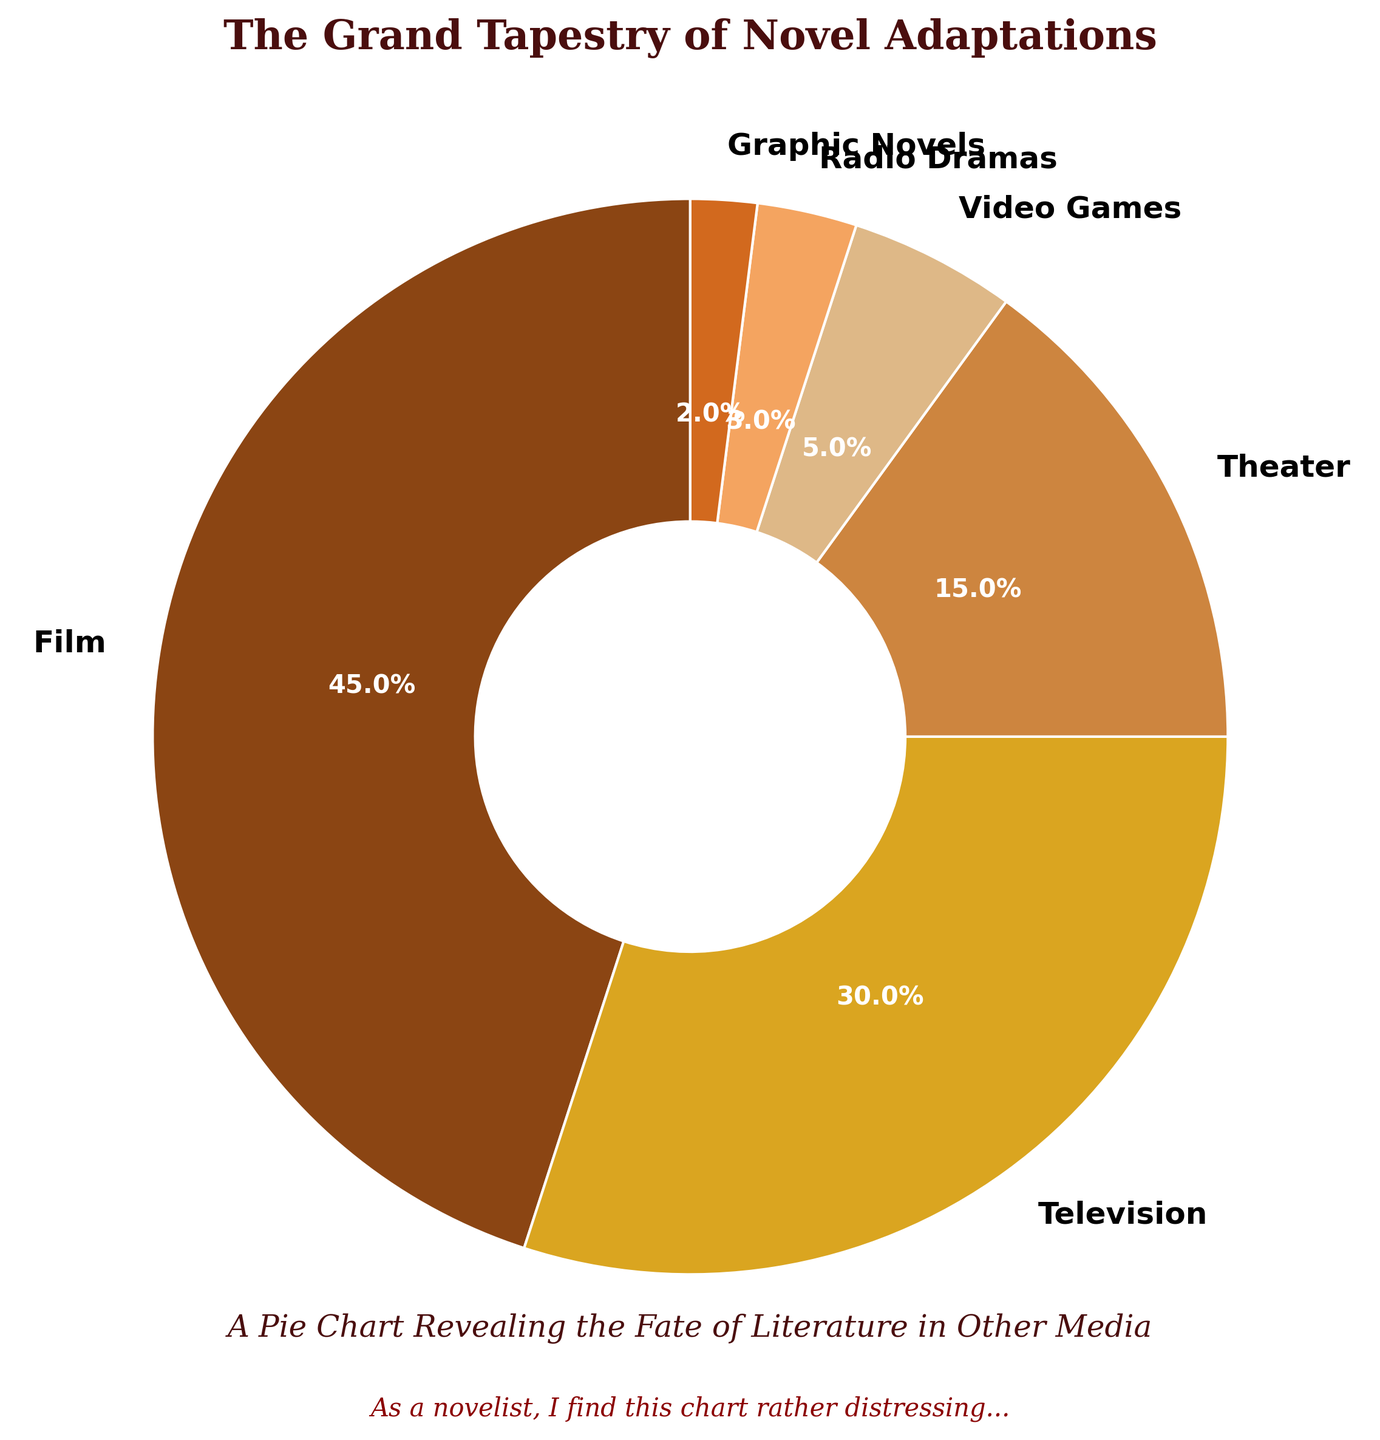what is the combined percentage of Film and Television adaptations? Film's percentage is 45% and Television's percentage is 30%. Summing them up, 45% + 30% = 75%.
Answer: 75% which medium has the smallest percentage of adaptations? Review all the percentages given (Film 45%, Television 30%, Theater 15%, Video Games 5%, Radio Dramas 3%, Graphic Novels 2%). Graphic Novels has the smallest percentage at 2%.
Answer: Graphic Novels is the percentage of Theater adaptations greater than that of Video Games and Radio Dramas combined? Theater has 15%, Video Games has 5%, and Radio Dramas have 3% according to the chart. Summing Video Games and Radio Dramas, 5% + 3% = 8%. Comparing this to Theater, 15% > 8%.
Answer: Yes what proportion of adaptations are in non-visual formats (Radio Dramas and Graphic Novels)? Radio Dramas account for 3% and Graphic Novels for 2%. Combined, they represent 3% + 2% = 5%. By checking all possible categories, the visual ones are: Film 45%, Television 30%, Theater 15%, Video Games 5%. So, the non-visual formats (Radio Dramas and Graphic Novels) constitute a total of 5%.
Answer: 5% out of Theater and Radio Dramas, which adaptation type is more frequent and by how much? Theater adaptations account for 15% whereas Radio Dramas account for 3%. Subtract the two, 15% - 3% = 12%.
Answer: Theater by 12% how do the combined percentage of adaptations to Video Games and Graphic Novels compare to Theater? Video Games have 5% and Graphic Novels have 2%. Combined, they yield 5% + 2% = 7%. Theater adaptations make up 15%. Therefore, Theater 15% - combined 7% = 8%.
Answer: Theater by 8% which color segment represents the biggest slice in the pie chart? Observing the chart, Film is represented by the largest slice at 45%, and its color is a shade of brown.
Answer: Brown what is the average percentage of Theater, Video Games, and Radio Dramas adaptations? Adding the percentages of these categories: Theater 15%, Video Games 5%, and Radio Dramas 3%. Their sum is 15% + 5% + 3% = 23%. Divide this by the number of categories, 23% / 3 ≈ 7.67%.
Answer: 7.67% 